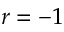Convert formula to latex. <formula><loc_0><loc_0><loc_500><loc_500>r = - 1</formula> 